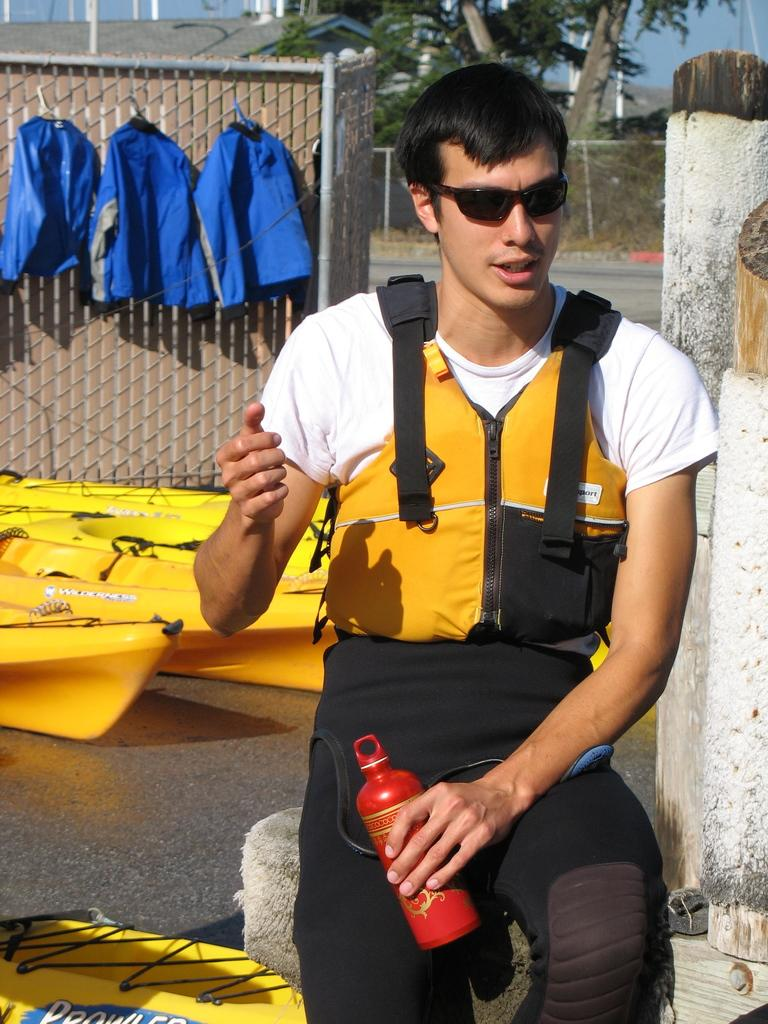What is the man wearing on his upper body in the image? The man is wearing a jacket in the image. What is the man wearing on his face in the image? The man is wearing goggles in the image. What is the man holding in the image? The man is holding a bottle in the image. What can be seen in the background of the image? There are jackets, yellow boats, and trees in the background of the image. What type of liquid is the man's mom pouring into the bottle in the image? There is no mention of the man's mom or any liquid in the image. 